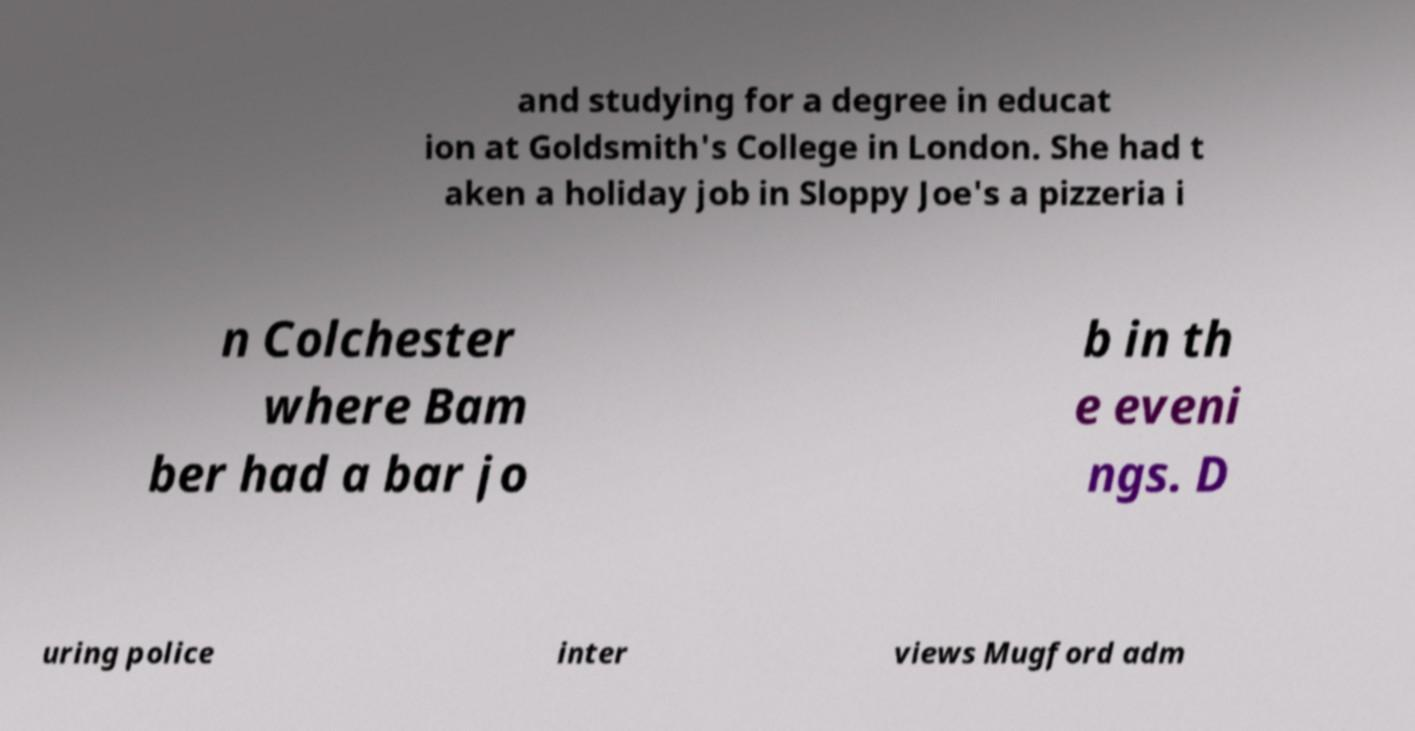Could you assist in decoding the text presented in this image and type it out clearly? and studying for a degree in educat ion at Goldsmith's College in London. She had t aken a holiday job in Sloppy Joe's a pizzeria i n Colchester where Bam ber had a bar jo b in th e eveni ngs. D uring police inter views Mugford adm 